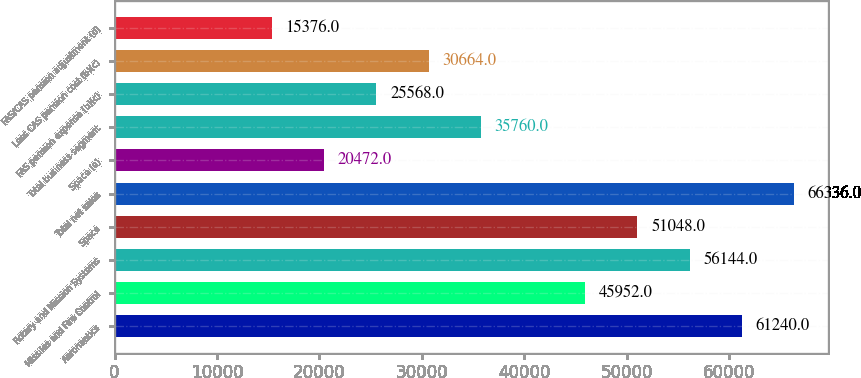<chart> <loc_0><loc_0><loc_500><loc_500><bar_chart><fcel>Aeronautics<fcel>Missiles and Fire Control<fcel>Rotary and Mission Systems<fcel>Space<fcel>Total net sales<fcel>Space (a)<fcel>Total business segment<fcel>FAS pension expense (b)(c)<fcel>Less CAS pension cost (b)(c)<fcel>FAS/CAS pension adjustment (d)<nl><fcel>61240<fcel>45952<fcel>56144<fcel>51048<fcel>66336<fcel>20472<fcel>35760<fcel>25568<fcel>30664<fcel>15376<nl></chart> 